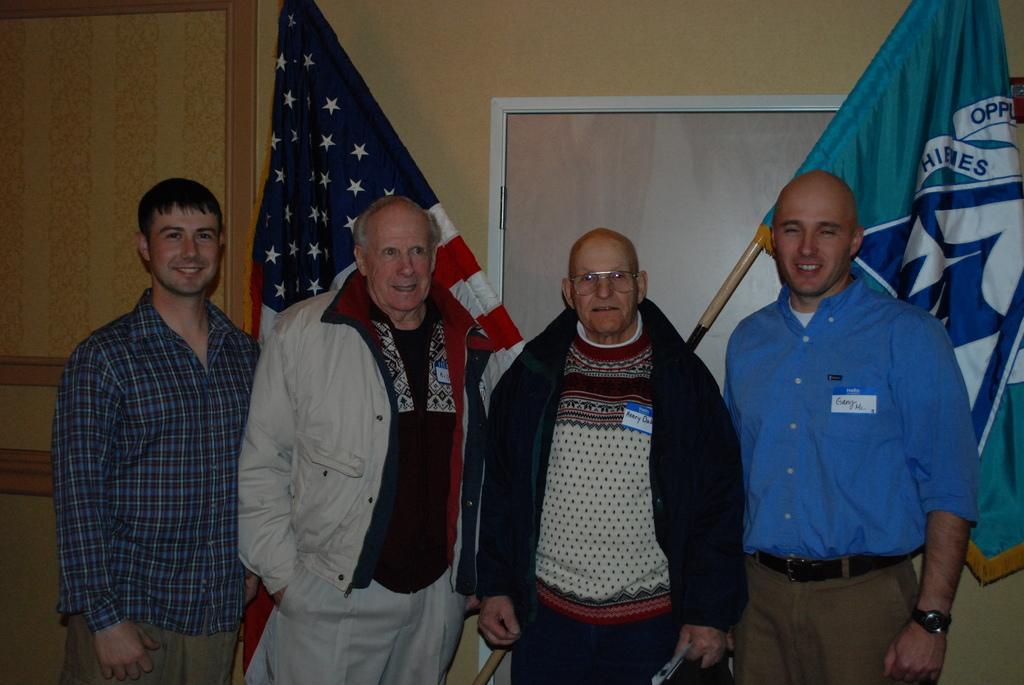Could you give a brief overview of what you see in this image? In this image there are four persons standing with a smile on their face, behind them there are flags, behind the flags there is a wooden wall with a door. 